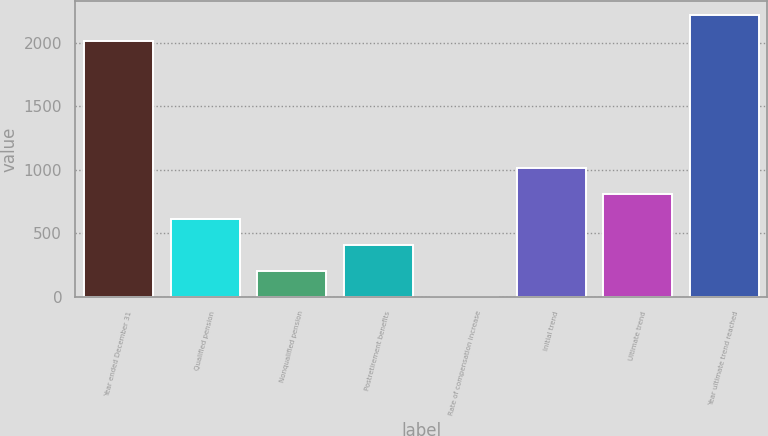<chart> <loc_0><loc_0><loc_500><loc_500><bar_chart><fcel>Year ended December 31<fcel>Qualified pension<fcel>Nonqualified pension<fcel>Postretirement benefits<fcel>Rate of compensation increase<fcel>Initial trend<fcel>Ultimate trend<fcel>Year ultimate trend reached<nl><fcel>2016<fcel>609.95<fcel>205.65<fcel>407.8<fcel>3.5<fcel>1014.25<fcel>812.1<fcel>2218.15<nl></chart> 